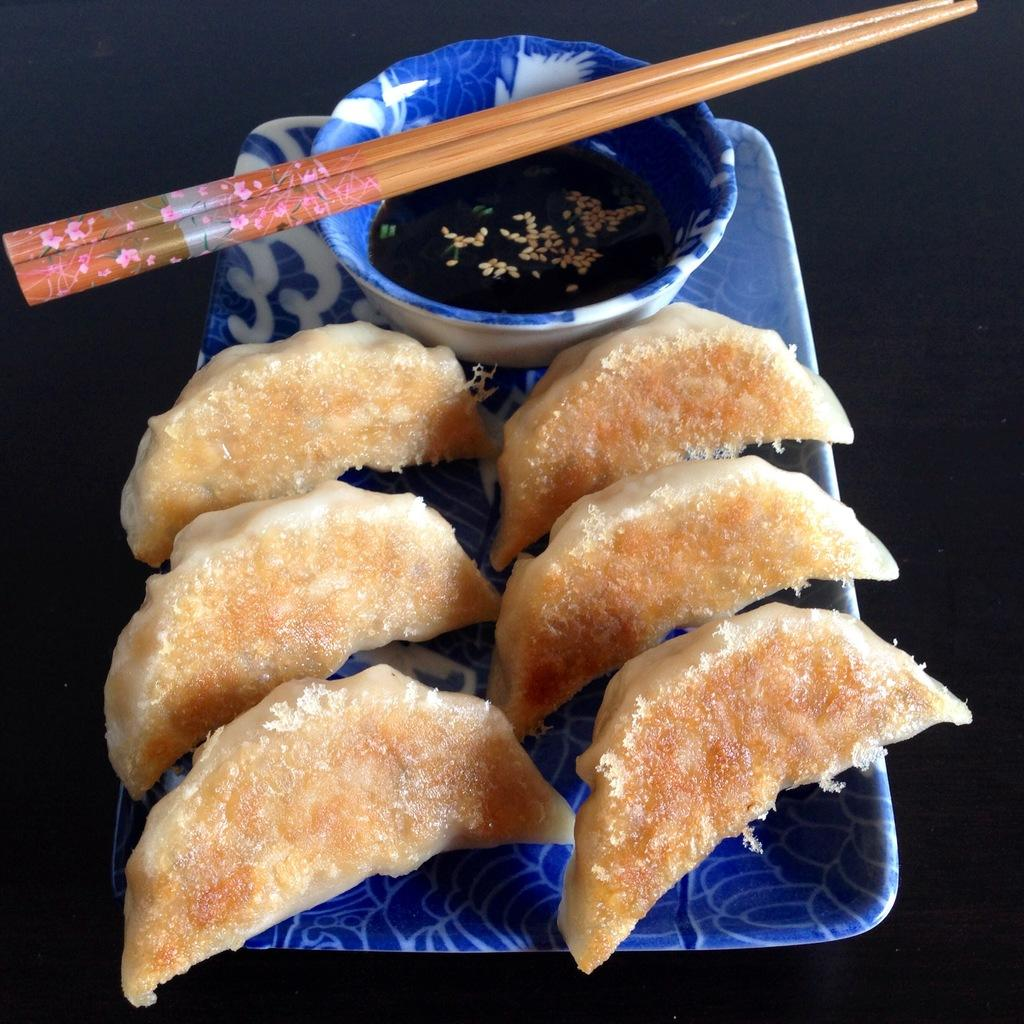What is the main object in the image? There is a tray in the image. How many slices are on the tray? There are six slices on the tray. What else is on the tray besides the slices? There is a bowl on the tray. What utensils are on the bowl? There are two chopsticks on the bowl. What type of toothbrush is being used to clean the spark off the society in the image? There is no toothbrush, spark, or society present in the image. 